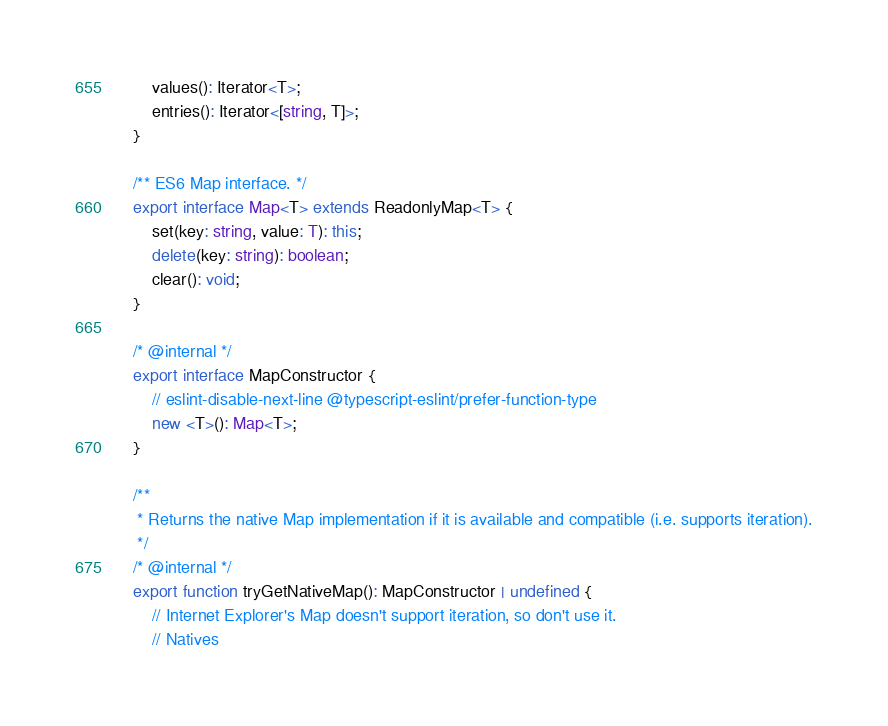<code> <loc_0><loc_0><loc_500><loc_500><_TypeScript_>        values(): Iterator<T>;
        entries(): Iterator<[string, T]>;
    }

    /** ES6 Map interface. */
    export interface Map<T> extends ReadonlyMap<T> {
        set(key: string, value: T): this;
        delete(key: string): boolean;
        clear(): void;
    }

    /* @internal */
    export interface MapConstructor {
        // eslint-disable-next-line @typescript-eslint/prefer-function-type
        new <T>(): Map<T>;
    }

    /**
     * Returns the native Map implementation if it is available and compatible (i.e. supports iteration).
     */
    /* @internal */
    export function tryGetNativeMap(): MapConstructor | undefined {
        // Internet Explorer's Map doesn't support iteration, so don't use it.
        // Natives</code> 